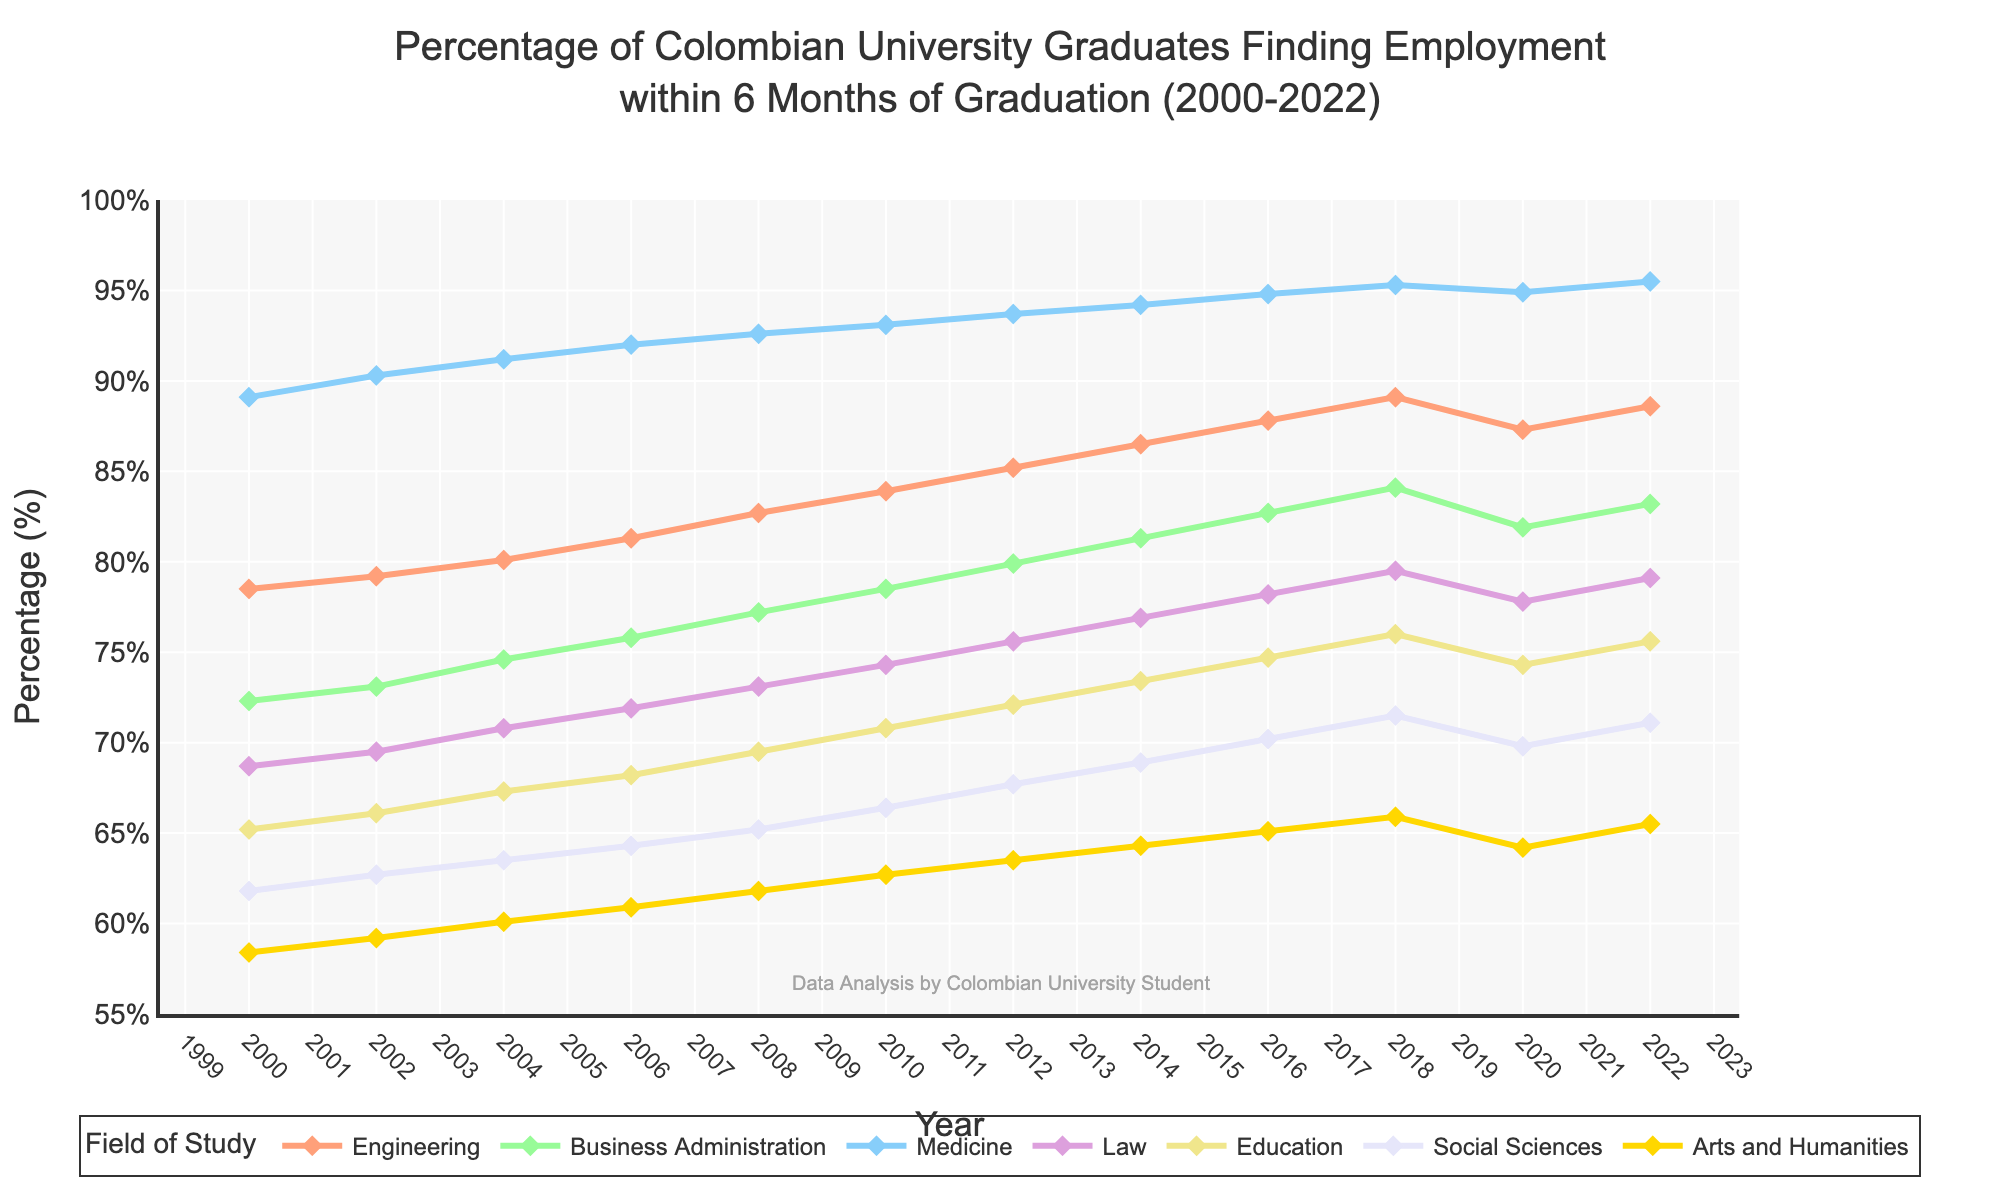What field had the highest percentage of graduates employed within 6 months in the year 2000? By visually inspecting the chart, the line that peaks the highest in 2000 represents Medicine, indicating that Medicine had the highest percentage.
Answer: Medicine How did the employment rate for Engineering change between 2010 and 2020? Look at the Engineering line in the years 2010 and 2020. In 2010, the value is around 83.9% and in 2020, it is around 87.3%. The difference is calculated as 87.3% - 83.9% . Thus, the employment rate for Engineering increased by 3.4%.
Answer: Increased by 3.4% Which field shows the greatest improvement in employment rates from 2000 to 2022? Calculate the difference in employment rates for each field between the years 2000 and 2022. Medicine starts at 89.1% and ends at 95.5% (6.4% increase), Engineering starts at 78.5% and ends at 88.6% (10.1% increase), and so on. The field with the highest increase is Engineering with a 10.1% improvement.
Answer: Engineering In 2018, what is the approximate percentage difference in employment rates between Business Administration and Law graduates? In 2018, find the percentage for Business Administration (84.1%) and for Law (79.5%). The difference is 84.1% - 79.5% = 4.6%.
Answer: 4.6% Which color corresponds to the field of Education in the plot? By referring to the legend, the color for Education is represented by yellow (or a specific shade depicted in the plot).
Answer: Yellow Between 2008 and 2010, which field showed the steepest increase in employment rate? Identify which line has the sharpest upward slope between 2008 and 2010. Observe that Medicine shows a steep increase from 92.6% to 93.1%, but Business Administration increases from 77.2% to 78.5%, which seems steeper on visual inspection.
Answer: Business Administration What is the average percentage of engineers employed across the entire time span given (2000-2022)? Sum the employment rates for Engineering for each year and divide by the number of years: (78.5 + 79.2 + 80.1 + 81.3 + 82.7 + 83.9 + 85.2 + 86.5 + 87.8 + 89.1 + 87.3 + 88.6) / 12 = 83.3%.
Answer: 83.3% In which year did Social Sciences graduates have a higher employment rate than Law graduates for the first time? Compare the lines for Social Sciences and Law. Social Sciences surpass Law in 2016, where Social Sciences are at 70.2% and Law is at 78.2%. Hence, Social Sciences had a higher employment rate than Law graduates before 2020.
Answer: No year before 2020 Which field’s employment rate decreased the most from 2018 to 2020? Compare the employment rates from 2018 to 2020 for all fields. The field with the largest drop is Medicine, which goes from 95.3% to 94.9%.
Answer: Medicine What is the median employment rate for Business Administration from 2000 to 2022? List the Business Administration employment rates in ascending order: [72.3, 73.1, 74.6, 75.8, 77.2, 78.5, 79.9, 81.3, 82.7, 84.1, 81.9, 83.2]. Since there are 12 data points, find the average of the 6th and 7th values: (78.5 + 79.9) / 2 = 79.2%.
Answer: 79.2% 